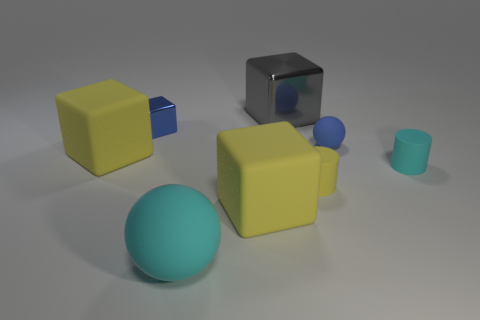Does the large metallic object have the same color as the big rubber ball?
Your answer should be very brief. No. What number of yellow things are tiny things or balls?
Give a very brief answer. 1. There is a small rubber ball; are there any small blue objects on the right side of it?
Your response must be concise. No. The blue shiny object has what size?
Offer a terse response. Small. There is a blue matte object that is the same shape as the large cyan thing; what is its size?
Your answer should be compact. Small. What number of small cyan rubber objects are on the left side of the cyan object that is in front of the small cyan thing?
Your response must be concise. 0. Is the material of the blue object that is to the left of the cyan rubber sphere the same as the small yellow cylinder in front of the small blue matte object?
Keep it short and to the point. No. How many gray shiny things have the same shape as the tiny yellow object?
Provide a succinct answer. 0. How many other tiny rubber spheres have the same color as the small ball?
Offer a terse response. 0. Do the shiny thing left of the large sphere and the small thing that is on the right side of the tiny rubber sphere have the same shape?
Your answer should be compact. No. 